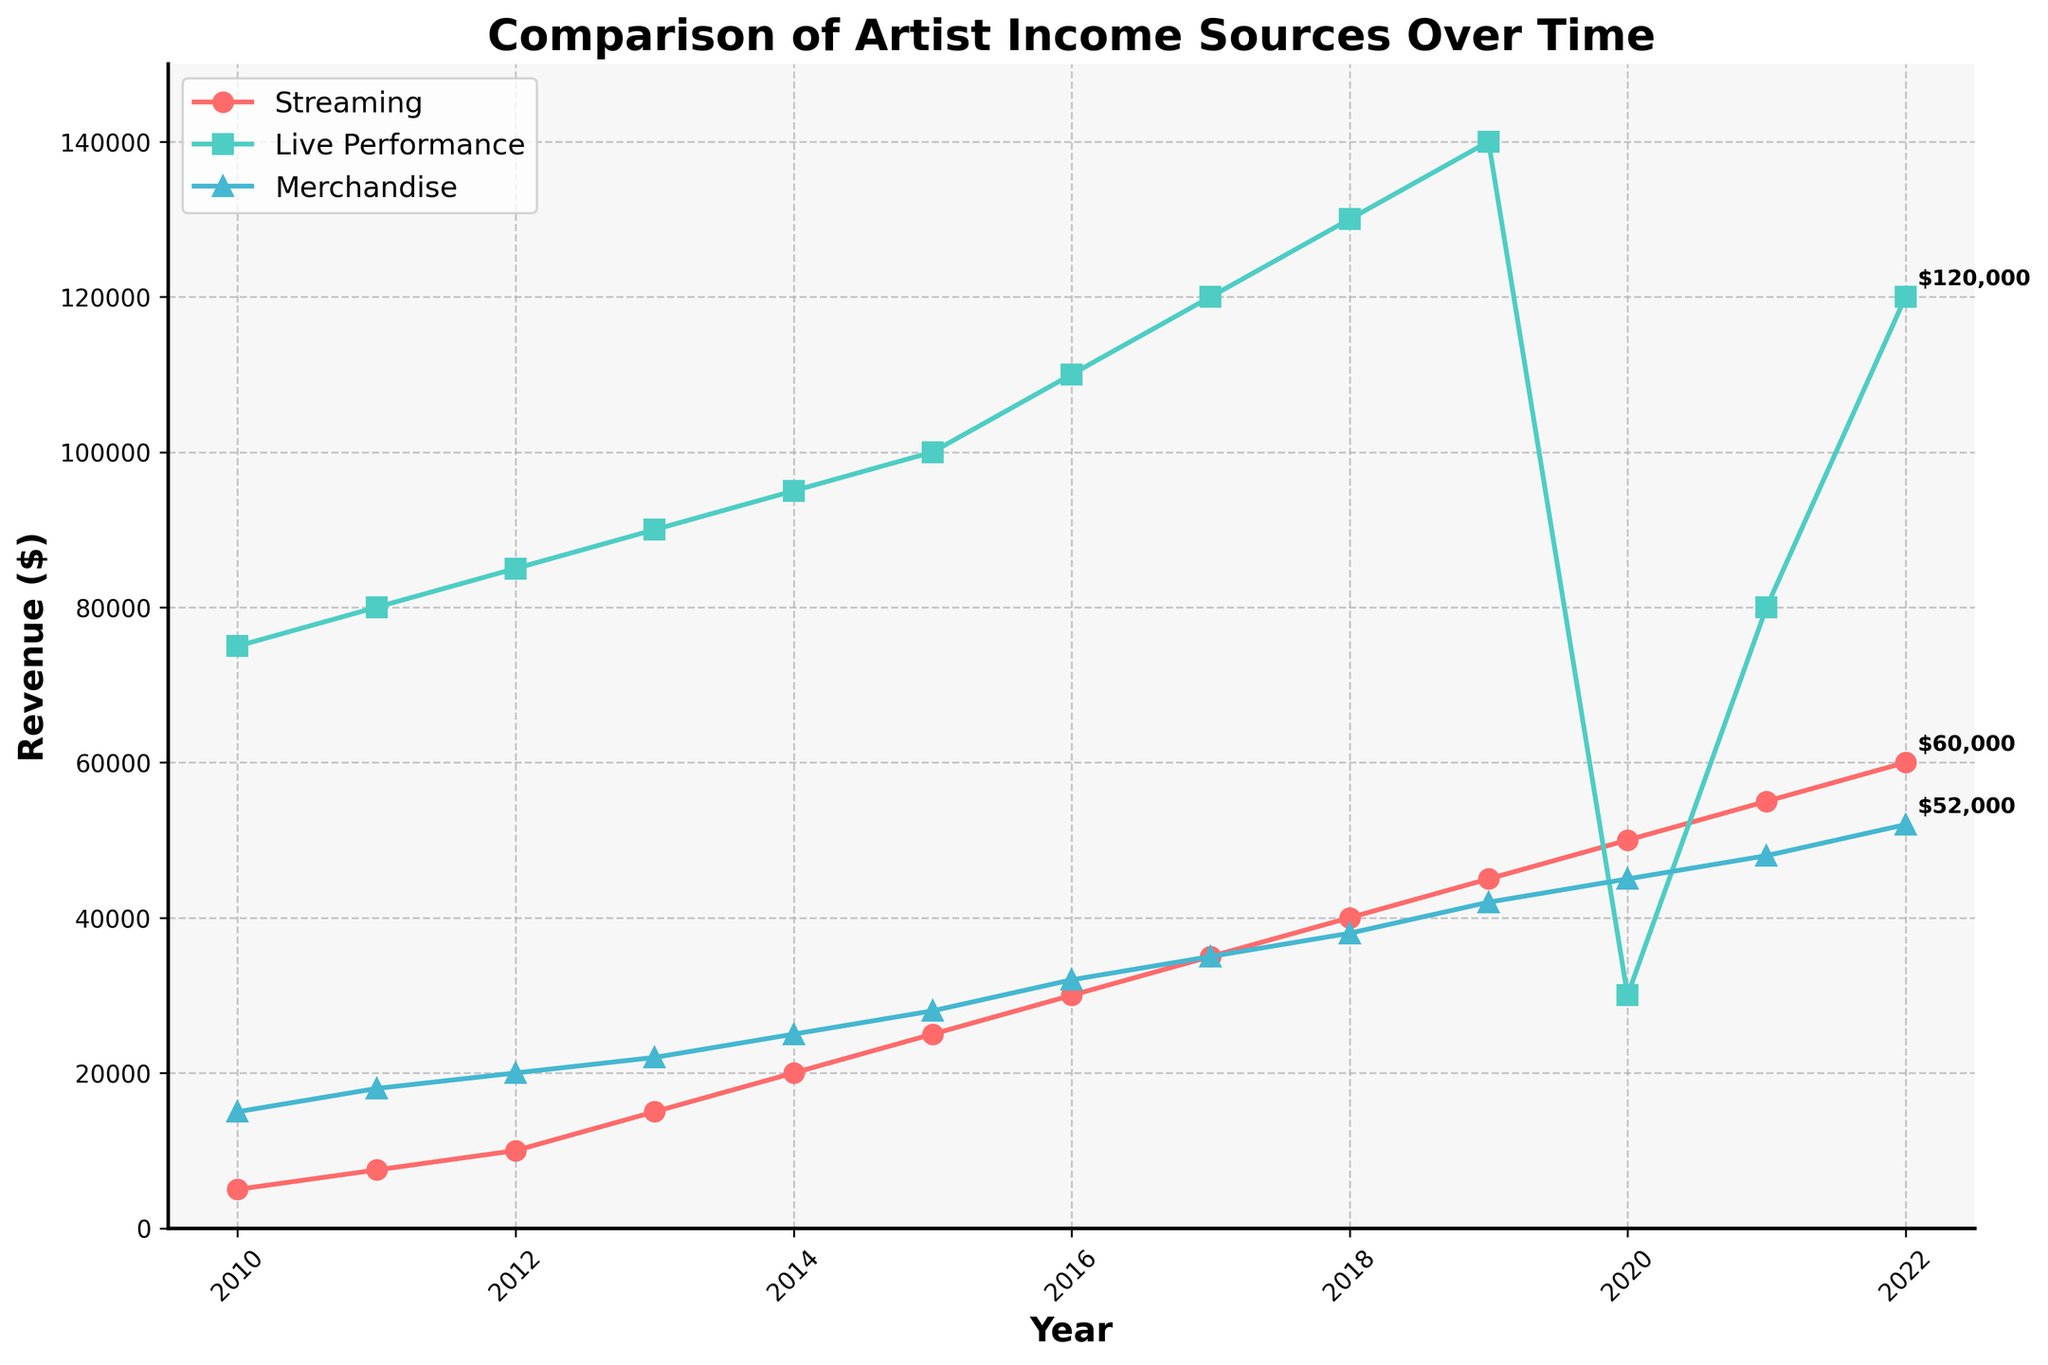Which revenue source showed the highest value in 2019? Observing the plot, live performance revenue is highest in 2019 compared to streaming and merchandise.
Answer: Live Performance When did streaming revenue first surpass merchandise revenue? By observing the plot, streaming revenue first surpasses merchandise revenue in 2014.
Answer: 2014 What is the total revenue from all sources in 2020? Add the values for streaming ($50,000), live performances ($30,000), and merchandise ($45,000) in 2020: $50,000 + $30,000 + $45,000.
Answer: $125,000 By how much did live performance revenue increase from 2010 to 2019? Subtract the live performance revenue in 2010 ($75,000) from the revenue in 2019 ($140,000): $140,000 - $75,000.
Answer: $65,000 Which revenue source experienced the largest decline between 2019 and 2020? Observe the slope changes between 2019 and 2020; live performance revenue saw a significant drop from $140,000 to $30,000.
Answer: Live Performance What trend do you observe in streaming revenue from 2010 to 2022? Streaming revenue consistently increases every year from $5,000 in 2010 to $60,000 in 2022.
Answer: Increasing Compare the difference in merchandise revenue between 2011 and 2022. Subtract the merchandise revenue in 2011 ($18,000) from the revenue in 2022 ($52,000): $52,000 - $18,000.
Answer: $34,000 How does the revenue pattern for live performances differ from streaming during 2020-2021? Live performance revenue drops drastically in 2020 and later increases, while streaming continues to rise steadily.
Answer: Live performances decline then rise, streaming rises steadily What is the average merchandise revenue from 2010 to 2022? Sum the merchandise revenues from 2010 to 2022 and divide by the number of years (13): ($15,000 + $18,000 + $20,000 + $22,000 + $25,000 + $28,000 + $32,000 + $35,000 + $38,000 + $42,000 + $45,000 + $48,000 + $52,000)/13. The sum is $420,000, so the average is $420,000/13.
Answer: $32,307.69 What year saw the largest increase in streaming revenue, and by how much did it increase? Compare the yearly differences; the largest increase is between 2019 ($45,000) and 2020 ($50,000): $50,000 - $45,000.
Answer: 2020, $5,000 